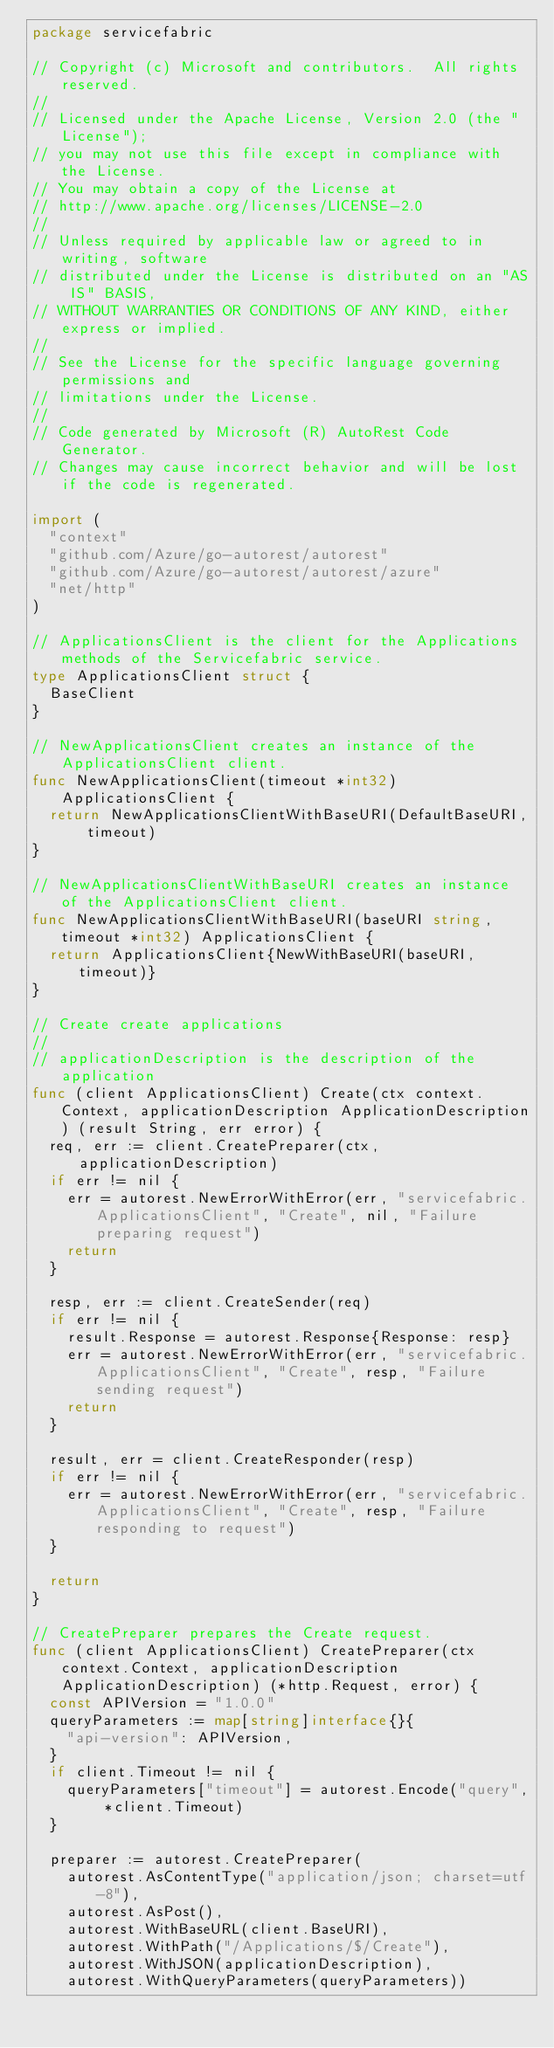Convert code to text. <code><loc_0><loc_0><loc_500><loc_500><_Go_>package servicefabric

// Copyright (c) Microsoft and contributors.  All rights reserved.
//
// Licensed under the Apache License, Version 2.0 (the "License");
// you may not use this file except in compliance with the License.
// You may obtain a copy of the License at
// http://www.apache.org/licenses/LICENSE-2.0
//
// Unless required by applicable law or agreed to in writing, software
// distributed under the License is distributed on an "AS IS" BASIS,
// WITHOUT WARRANTIES OR CONDITIONS OF ANY KIND, either express or implied.
//
// See the License for the specific language governing permissions and
// limitations under the License.
//
// Code generated by Microsoft (R) AutoRest Code Generator.
// Changes may cause incorrect behavior and will be lost if the code is regenerated.

import (
	"context"
	"github.com/Azure/go-autorest/autorest"
	"github.com/Azure/go-autorest/autorest/azure"
	"net/http"
)

// ApplicationsClient is the client for the Applications methods of the Servicefabric service.
type ApplicationsClient struct {
	BaseClient
}

// NewApplicationsClient creates an instance of the ApplicationsClient client.
func NewApplicationsClient(timeout *int32) ApplicationsClient {
	return NewApplicationsClientWithBaseURI(DefaultBaseURI, timeout)
}

// NewApplicationsClientWithBaseURI creates an instance of the ApplicationsClient client.
func NewApplicationsClientWithBaseURI(baseURI string, timeout *int32) ApplicationsClient {
	return ApplicationsClient{NewWithBaseURI(baseURI, timeout)}
}

// Create create applications
//
// applicationDescription is the description of the application
func (client ApplicationsClient) Create(ctx context.Context, applicationDescription ApplicationDescription) (result String, err error) {
	req, err := client.CreatePreparer(ctx, applicationDescription)
	if err != nil {
		err = autorest.NewErrorWithError(err, "servicefabric.ApplicationsClient", "Create", nil, "Failure preparing request")
		return
	}

	resp, err := client.CreateSender(req)
	if err != nil {
		result.Response = autorest.Response{Response: resp}
		err = autorest.NewErrorWithError(err, "servicefabric.ApplicationsClient", "Create", resp, "Failure sending request")
		return
	}

	result, err = client.CreateResponder(resp)
	if err != nil {
		err = autorest.NewErrorWithError(err, "servicefabric.ApplicationsClient", "Create", resp, "Failure responding to request")
	}

	return
}

// CreatePreparer prepares the Create request.
func (client ApplicationsClient) CreatePreparer(ctx context.Context, applicationDescription ApplicationDescription) (*http.Request, error) {
	const APIVersion = "1.0.0"
	queryParameters := map[string]interface{}{
		"api-version": APIVersion,
	}
	if client.Timeout != nil {
		queryParameters["timeout"] = autorest.Encode("query", *client.Timeout)
	}

	preparer := autorest.CreatePreparer(
		autorest.AsContentType("application/json; charset=utf-8"),
		autorest.AsPost(),
		autorest.WithBaseURL(client.BaseURI),
		autorest.WithPath("/Applications/$/Create"),
		autorest.WithJSON(applicationDescription),
		autorest.WithQueryParameters(queryParameters))</code> 